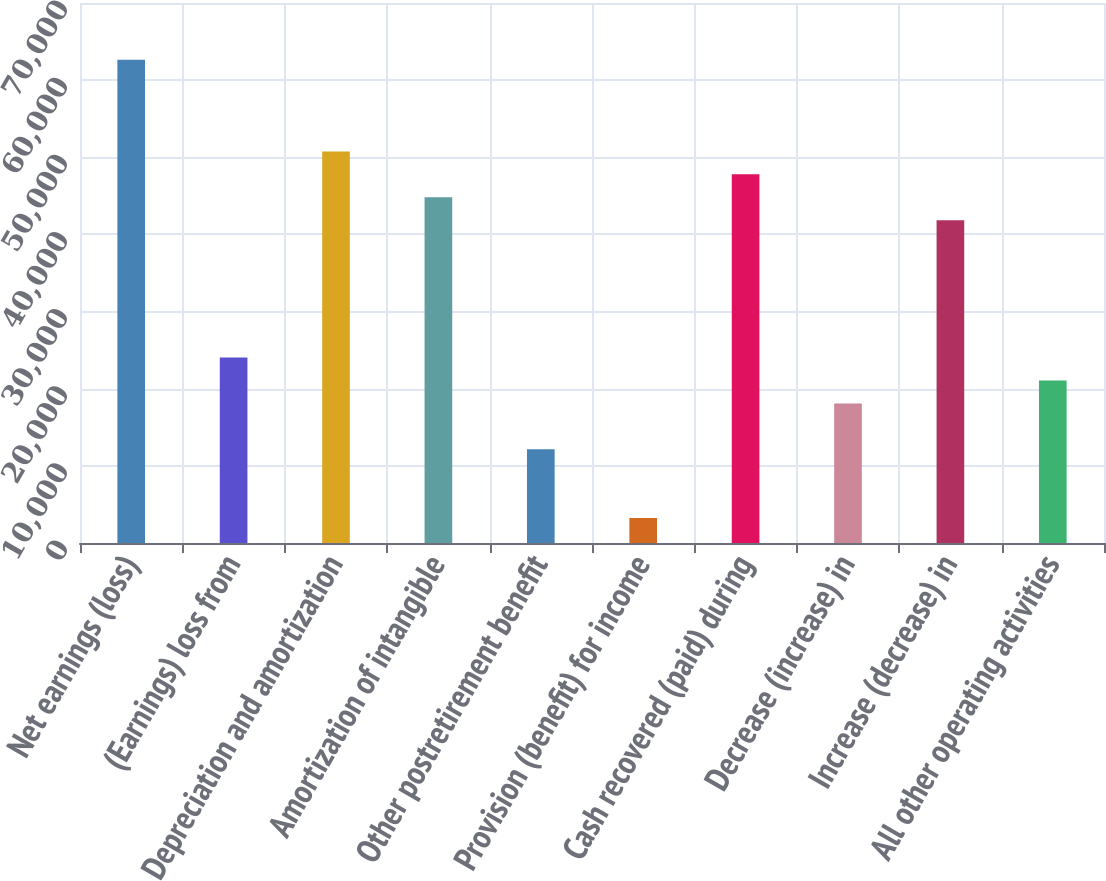<chart> <loc_0><loc_0><loc_500><loc_500><bar_chart><fcel>Net earnings (loss)<fcel>(Earnings) loss from<fcel>Depreciation and amortization<fcel>Amortization of intangible<fcel>Other postretirement benefit<fcel>Provision (benefit) for income<fcel>Cash recovered (paid) during<fcel>Decrease (increase) in<fcel>Increase (decrease) in<fcel>All other operating activities<nl><fcel>62640.9<fcel>24032.2<fcel>50761.3<fcel>44821.5<fcel>12152.6<fcel>3242.9<fcel>47791.4<fcel>18092.4<fcel>41851.6<fcel>21062.3<nl></chart> 